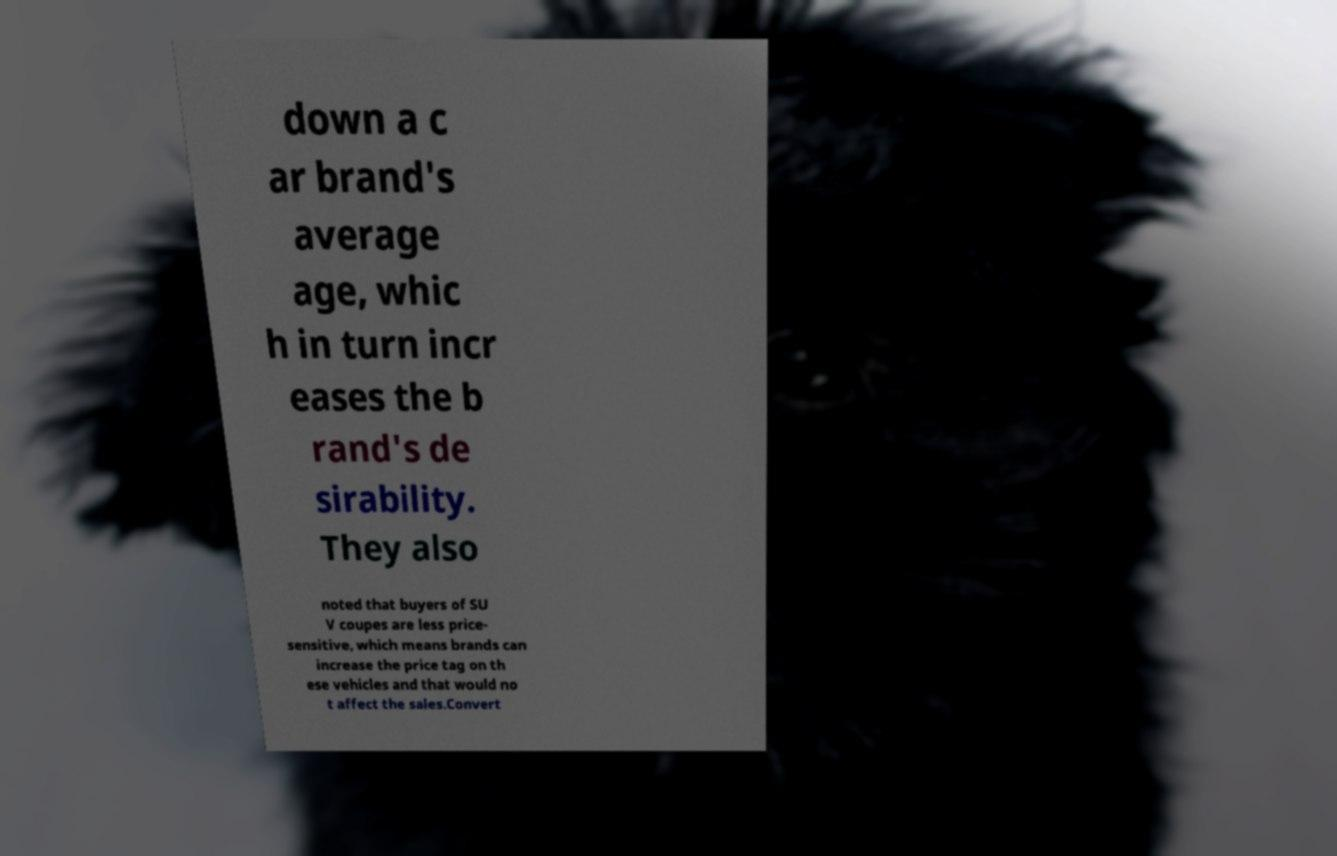Please identify and transcribe the text found in this image. down a c ar brand's average age, whic h in turn incr eases the b rand's de sirability. They also noted that buyers of SU V coupes are less price- sensitive, which means brands can increase the price tag on th ese vehicles and that would no t affect the sales.Convert 